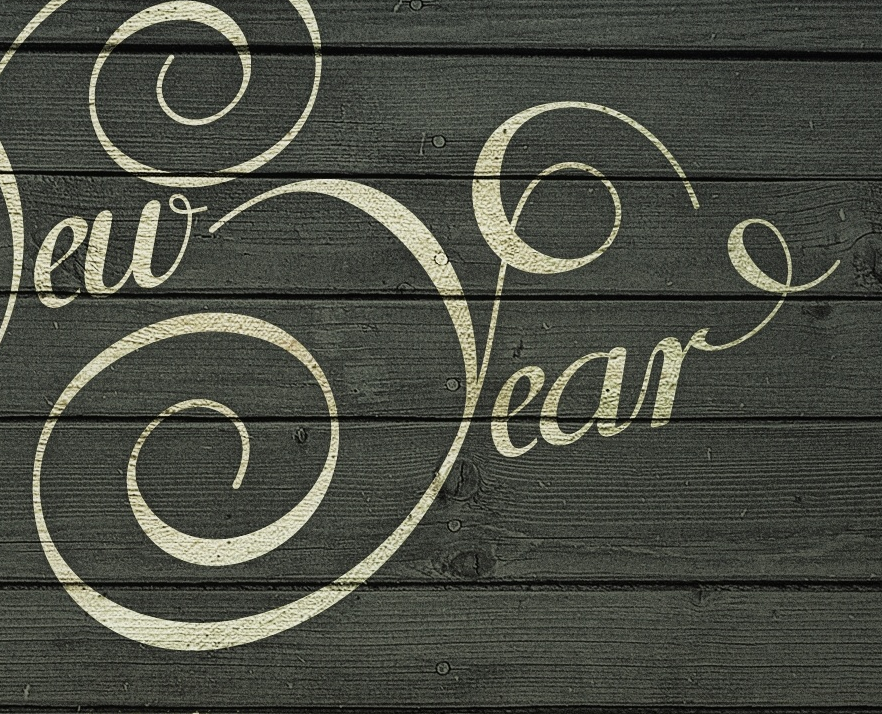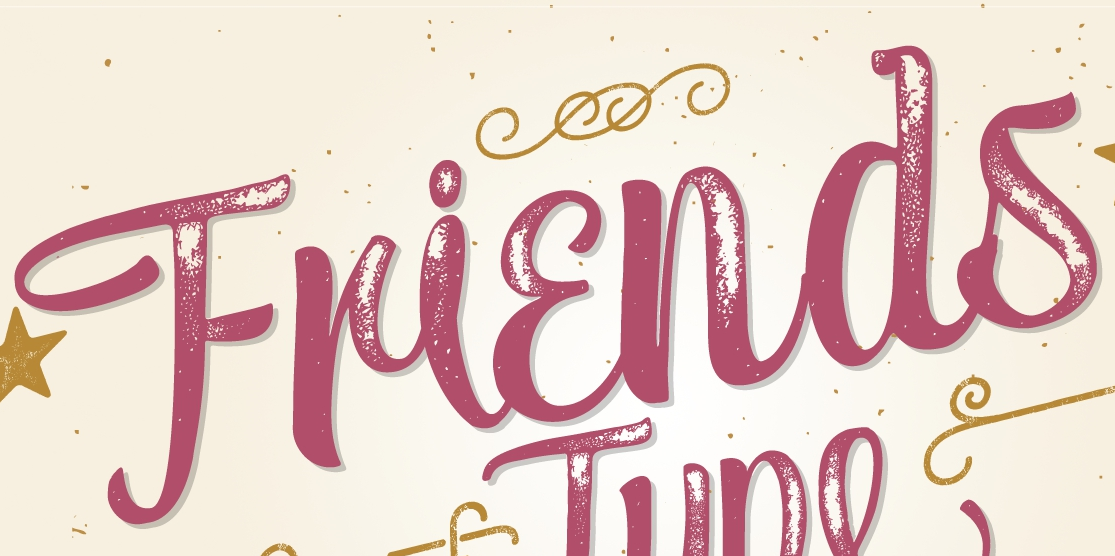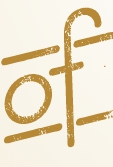Read the text from these images in sequence, separated by a semicolon. Year; Friends; of 